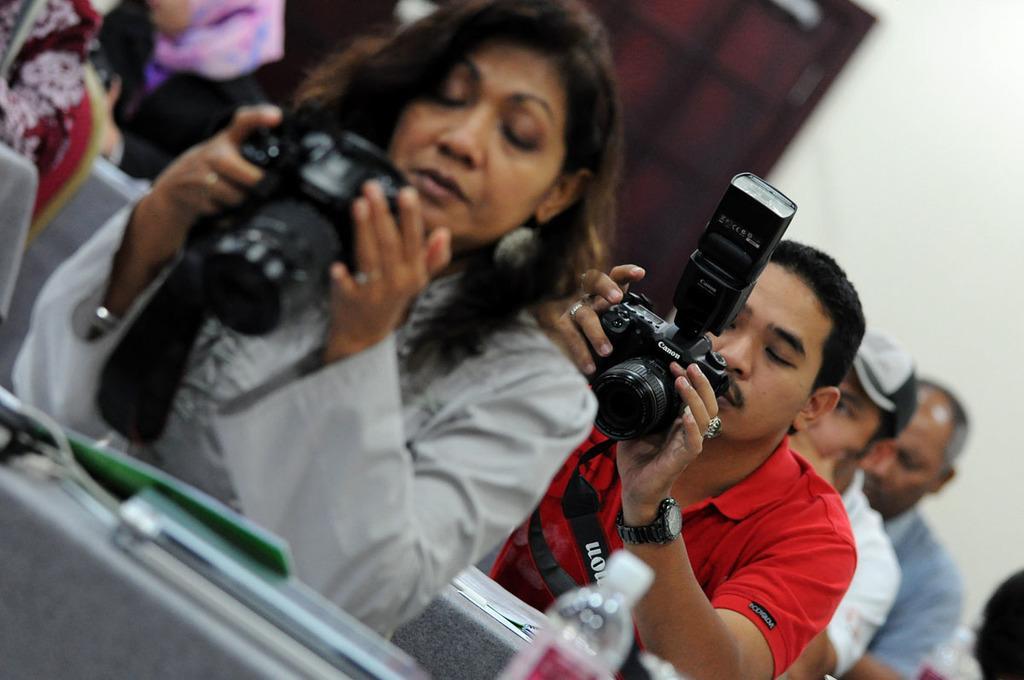Could you give a brief overview of what you see in this image? In this image I can see few people are holding cameras in their hands and looking at the cameras. In the background there is a wall. 